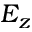Convert formula to latex. <formula><loc_0><loc_0><loc_500><loc_500>E _ { z }</formula> 